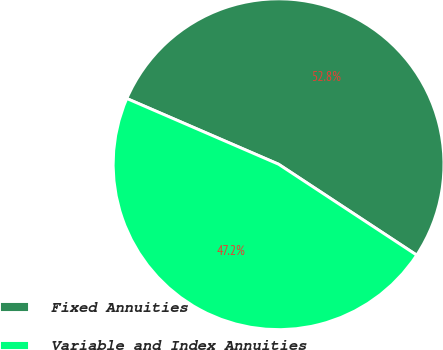<chart> <loc_0><loc_0><loc_500><loc_500><pie_chart><fcel>Fixed Annuities<fcel>Variable and Index Annuities<nl><fcel>52.76%<fcel>47.24%<nl></chart> 